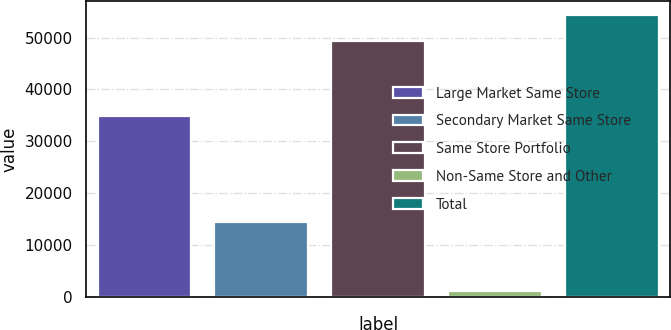<chart> <loc_0><loc_0><loc_500><loc_500><bar_chart><fcel>Large Market Same Store<fcel>Secondary Market Same Store<fcel>Same Store Portfolio<fcel>Non-Same Store and Other<fcel>Total<nl><fcel>34858<fcel>14490<fcel>49348<fcel>1253<fcel>54282.8<nl></chart> 